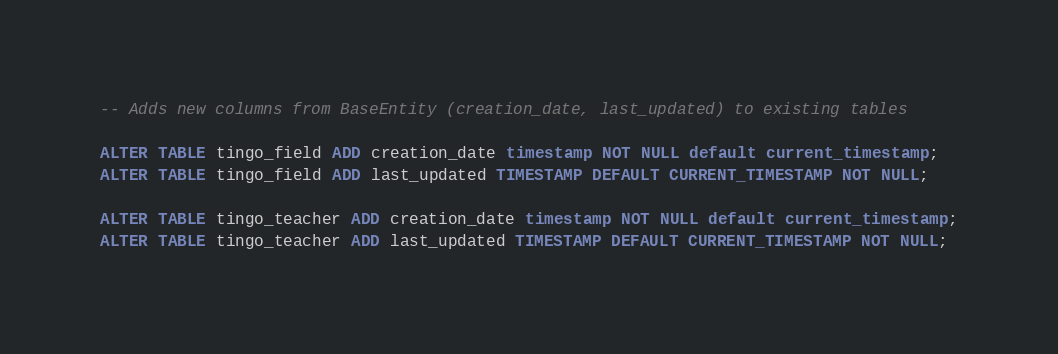Convert code to text. <code><loc_0><loc_0><loc_500><loc_500><_SQL_>-- Adds new columns from BaseEntity (creation_date, last_updated) to existing tables

ALTER TABLE tingo_field ADD creation_date timestamp NOT NULL default current_timestamp;
ALTER TABLE tingo_field ADD last_updated TIMESTAMP DEFAULT CURRENT_TIMESTAMP NOT NULL;

ALTER TABLE tingo_teacher ADD creation_date timestamp NOT NULL default current_timestamp;
ALTER TABLE tingo_teacher ADD last_updated TIMESTAMP DEFAULT CURRENT_TIMESTAMP NOT NULL;
</code> 